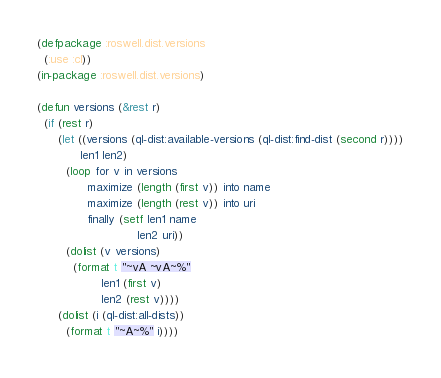<code> <loc_0><loc_0><loc_500><loc_500><_Lisp_>(defpackage :roswell.dist.versions
  (:use :cl))
(in-package :roswell.dist.versions)

(defun versions (&rest r)
  (if (rest r)
      (let ((versions (ql-dist:available-versions (ql-dist:find-dist (second r))))
            len1 len2)
        (loop for v in versions
              maximize (length (first v)) into name
              maximize (length (rest v)) into uri
              finally (setf len1 name
                            len2 uri))
        (dolist (v versions)
          (format t "~vA ~vA~%"
                  len1 (first v)
                  len2 (rest v))))
      (dolist (i (ql-dist:all-dists))
        (format t "~A~%" i))))
</code> 